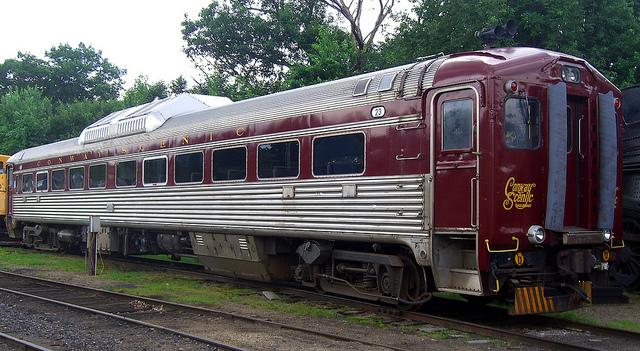Is this the engine of the train?
Short answer required. No. Is the red color of this train the same color as a fire truck?
Quick response, please. No. How many windows are on the train?
Be succinct. 14. 